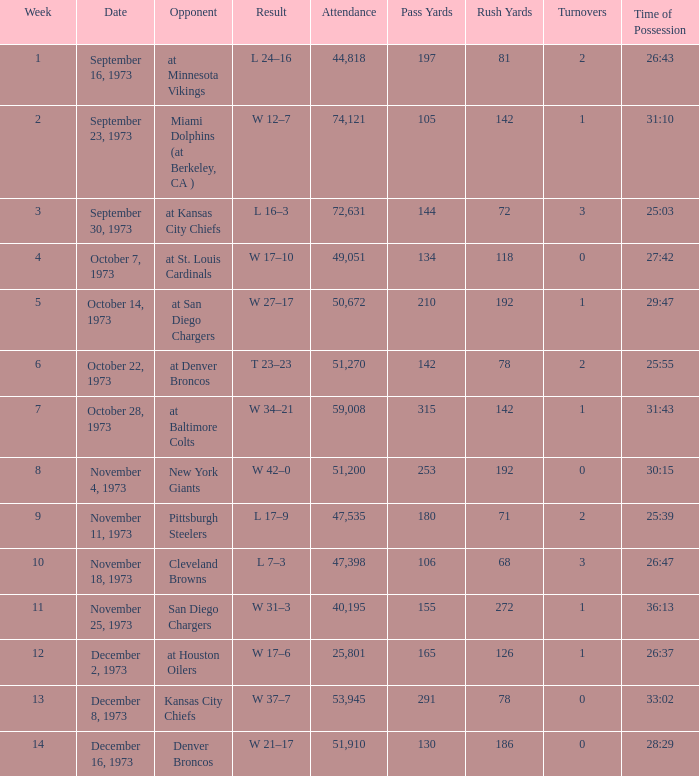What is the result later than week 13? W 21–17. 